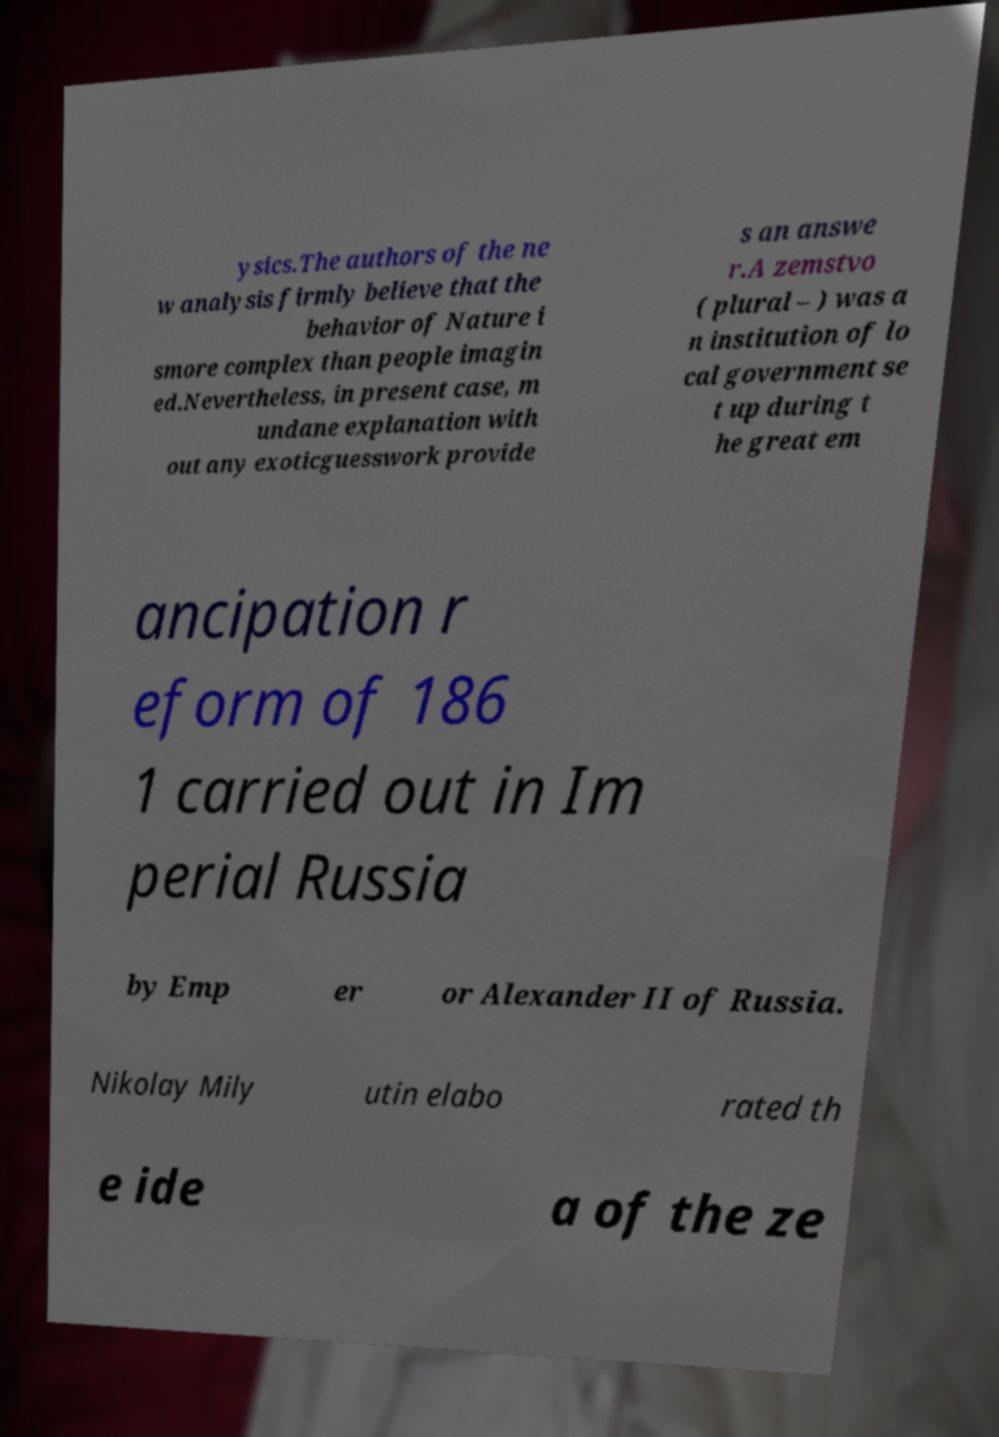Could you assist in decoding the text presented in this image and type it out clearly? ysics.The authors of the ne w analysis firmly believe that the behavior of Nature i smore complex than people imagin ed.Nevertheless, in present case, m undane explanation with out any exoticguesswork provide s an answe r.A zemstvo ( plural – ) was a n institution of lo cal government se t up during t he great em ancipation r eform of 186 1 carried out in Im perial Russia by Emp er or Alexander II of Russia. Nikolay Mily utin elabo rated th e ide a of the ze 